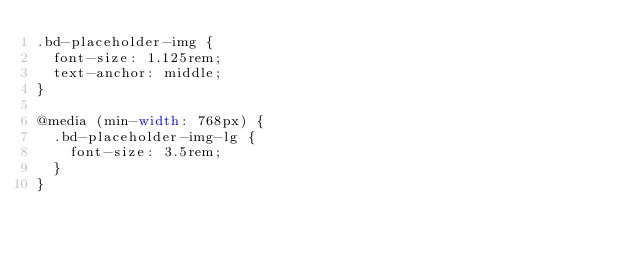<code> <loc_0><loc_0><loc_500><loc_500><_CSS_>.bd-placeholder-img {
  font-size: 1.125rem;
  text-anchor: middle;
}

@media (min-width: 768px) {
  .bd-placeholder-img-lg {
    font-size: 3.5rem;
  }
}</code> 